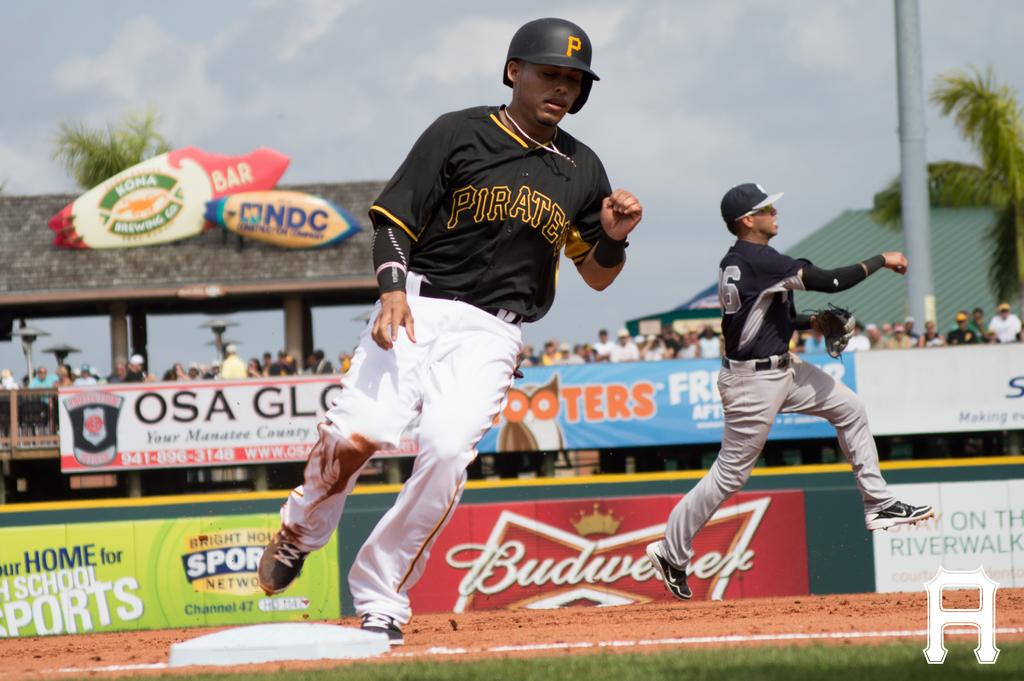<image>
Write a terse but informative summary of the picture. A player for the Pittsburgh Pirates is running around the bases during a baseball game. 